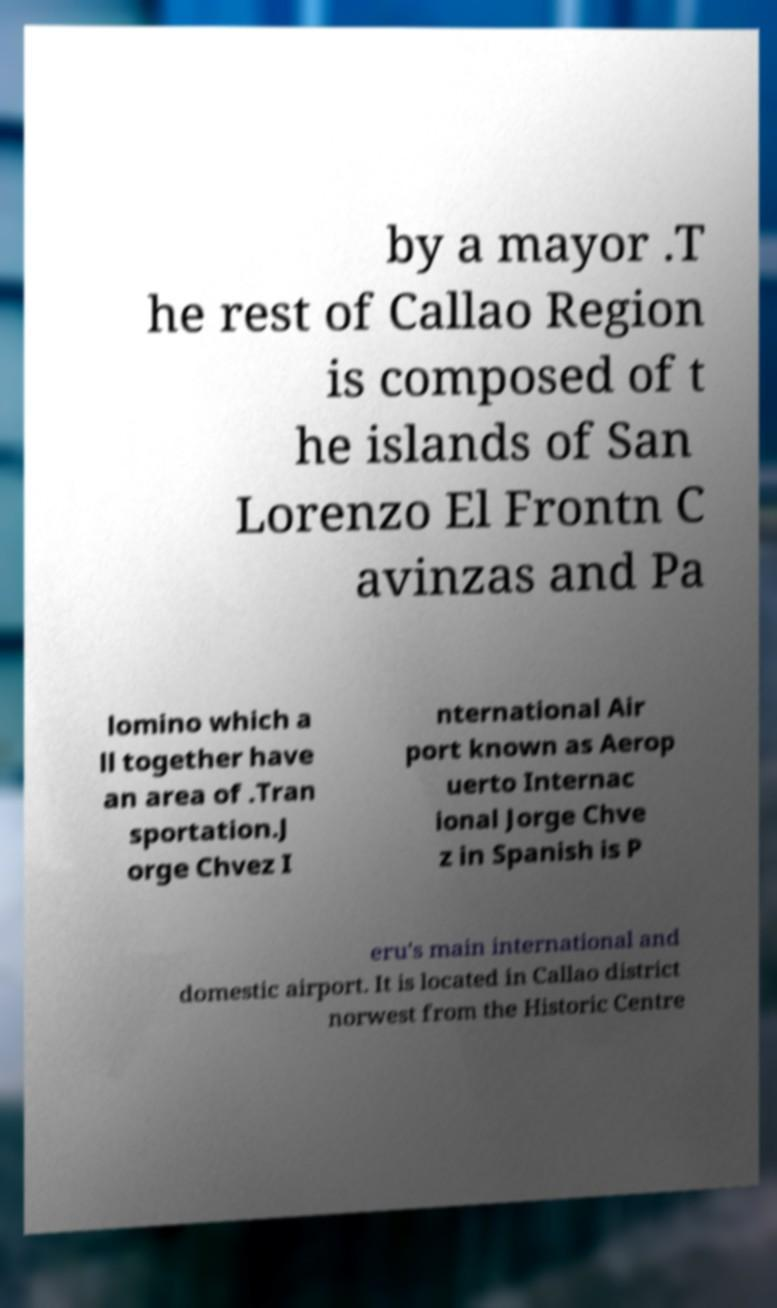Please read and relay the text visible in this image. What does it say? by a mayor .T he rest of Callao Region is composed of t he islands of San Lorenzo El Frontn C avinzas and Pa lomino which a ll together have an area of .Tran sportation.J orge Chvez I nternational Air port known as Aerop uerto Internac ional Jorge Chve z in Spanish is P eru's main international and domestic airport. It is located in Callao district norwest from the Historic Centre 